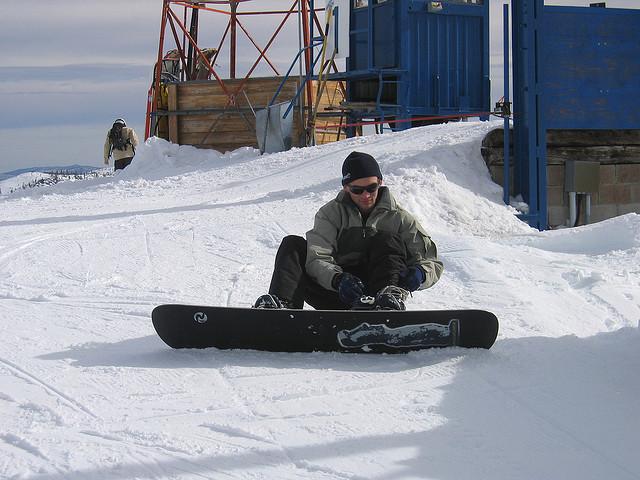Is he sitting down?
Short answer required. Yes. Did he fall?
Keep it brief. No. What type of sporting equipment is featured in the picture?
Keep it brief. Snowboard. 